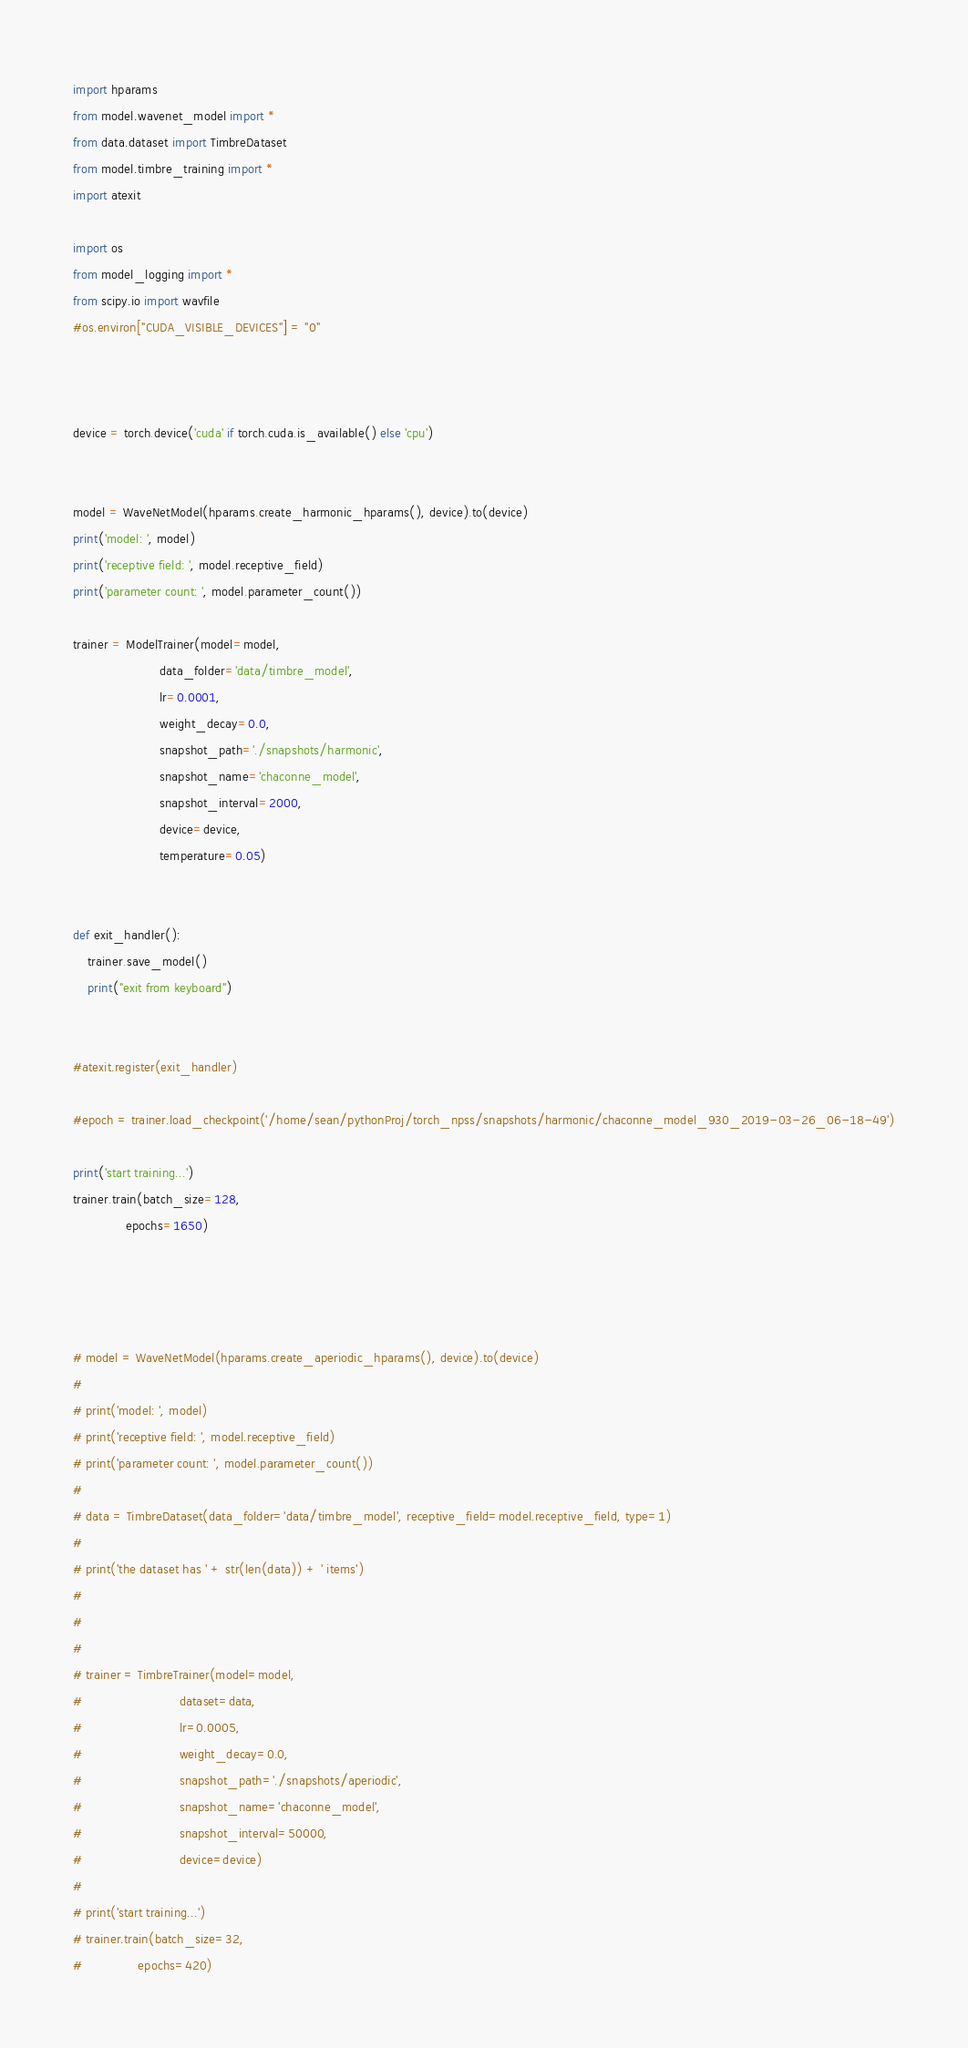Convert code to text. <code><loc_0><loc_0><loc_500><loc_500><_Python_>import hparams
from model.wavenet_model import *
from data.dataset import TimbreDataset
from model.timbre_training import *
import atexit

import os
from model_logging import *
from scipy.io import wavfile
#os.environ["CUDA_VISIBLE_DEVICES"] = "0"



device = torch.device('cuda' if torch.cuda.is_available() else 'cpu')


model = WaveNetModel(hparams.create_harmonic_hparams(), device).to(device)
print('model: ', model)
print('receptive field: ', model.receptive_field)
print('parameter count: ', model.parameter_count())

trainer = ModelTrainer(model=model,
                       data_folder='data/timbre_model',
                       lr=0.0001,
                       weight_decay=0.0,
                       snapshot_path='./snapshots/harmonic',
                       snapshot_name='chaconne_model',
                       snapshot_interval=2000,
                       device=device,
                       temperature=0.05)


def exit_handler():
    trainer.save_model()
    print("exit from keyboard")


#atexit.register(exit_handler)

#epoch = trainer.load_checkpoint('/home/sean/pythonProj/torch_npss/snapshots/harmonic/chaconne_model_930_2019-03-26_06-18-49')

print('start training...')
trainer.train(batch_size=128,
              epochs=1650)




# model = WaveNetModel(hparams.create_aperiodic_hparams(), device).to(device)
#
# print('model: ', model)
# print('receptive field: ', model.receptive_field)
# print('parameter count: ', model.parameter_count())
#
# data = TimbreDataset(data_folder='data/timbre_model', receptive_field=model.receptive_field, type=1)
#
# print('the dataset has ' + str(len(data)) + ' items')
#
#
#
# trainer = TimbreTrainer(model=model,
#                          dataset=data,
#                          lr=0.0005,
#                          weight_decay=0.0,
#                          snapshot_path='./snapshots/aperiodic',
#                          snapshot_name='chaconne_model',
#                          snapshot_interval=50000,
#                          device=device)
#
# print('start training...')
# trainer.train(batch_size=32,
#               epochs=420)

</code> 